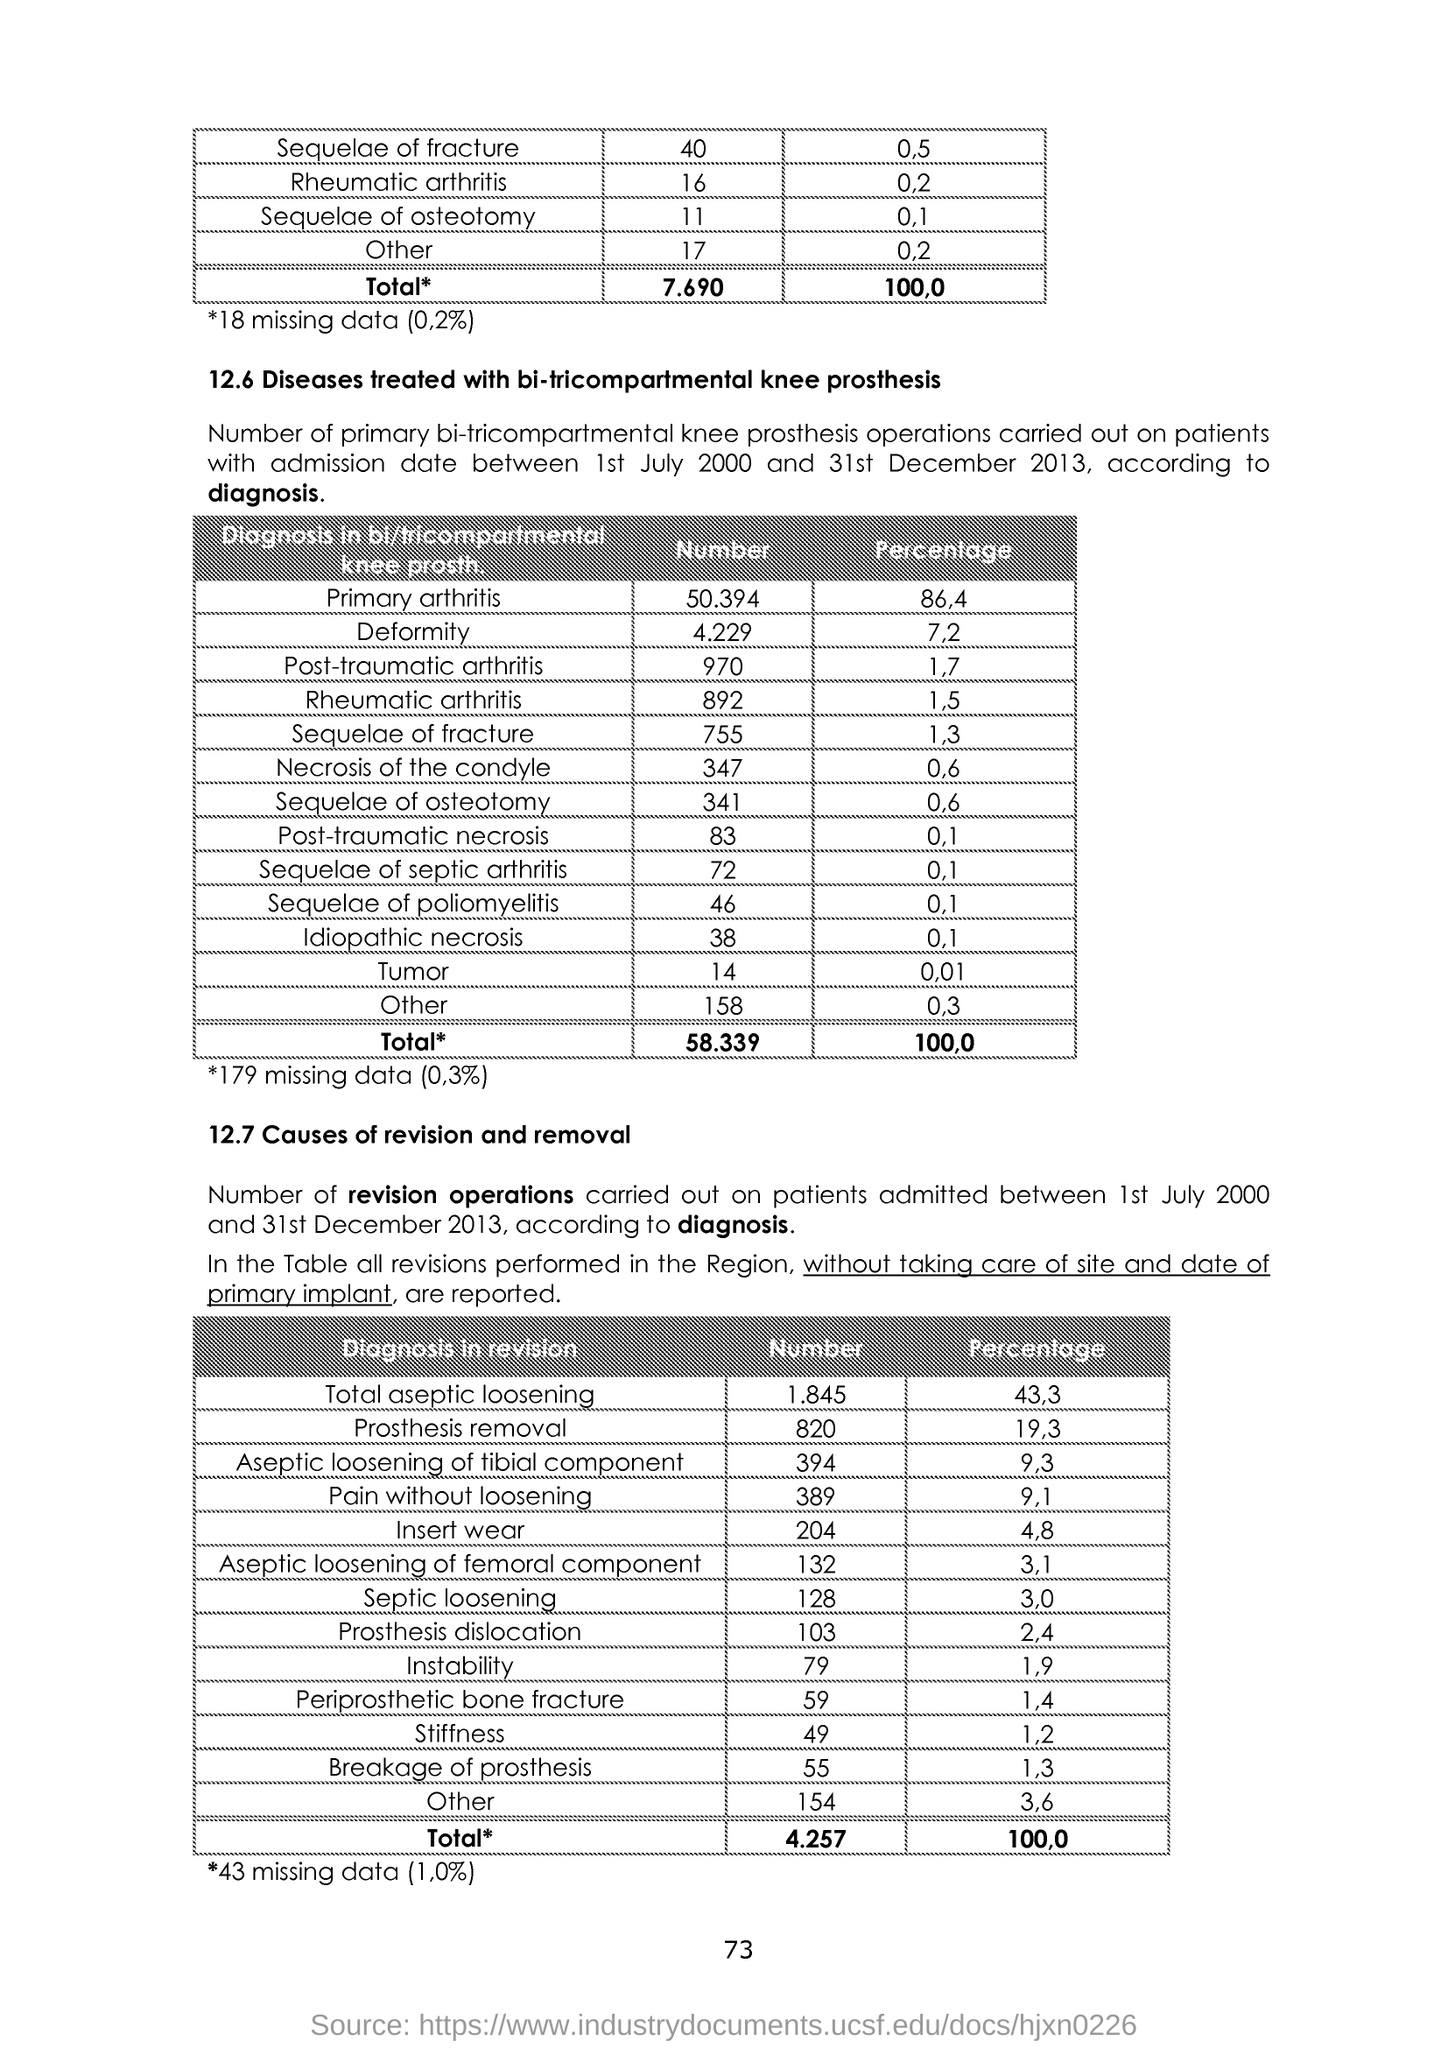Specify some key components in this picture. The dislocation rate for Prosthesis is 2.4%. According to the data provided, there were 820 instances of prosthesis removal. 